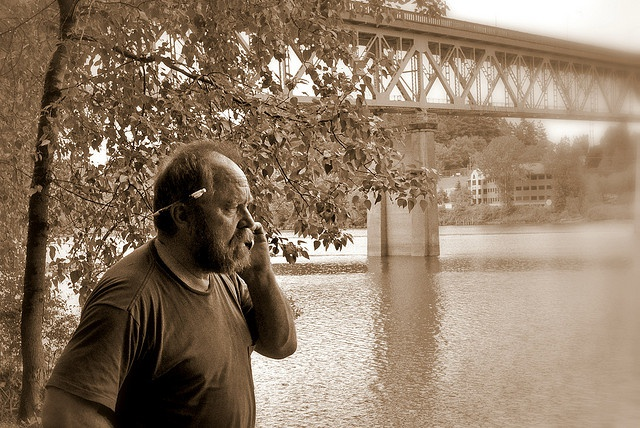Describe the objects in this image and their specific colors. I can see people in gray, black, and maroon tones and cell phone in gray, black, maroon, and tan tones in this image. 